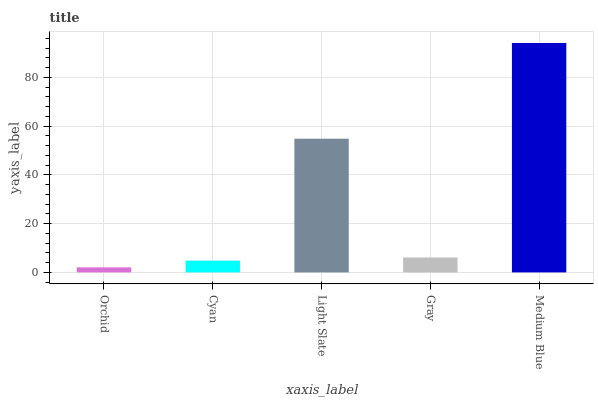Is Orchid the minimum?
Answer yes or no. Yes. Is Medium Blue the maximum?
Answer yes or no. Yes. Is Cyan the minimum?
Answer yes or no. No. Is Cyan the maximum?
Answer yes or no. No. Is Cyan greater than Orchid?
Answer yes or no. Yes. Is Orchid less than Cyan?
Answer yes or no. Yes. Is Orchid greater than Cyan?
Answer yes or no. No. Is Cyan less than Orchid?
Answer yes or no. No. Is Gray the high median?
Answer yes or no. Yes. Is Gray the low median?
Answer yes or no. Yes. Is Medium Blue the high median?
Answer yes or no. No. Is Cyan the low median?
Answer yes or no. No. 